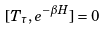Convert formula to latex. <formula><loc_0><loc_0><loc_500><loc_500>[ T _ { \tau } , e ^ { - \beta H } ] = 0</formula> 